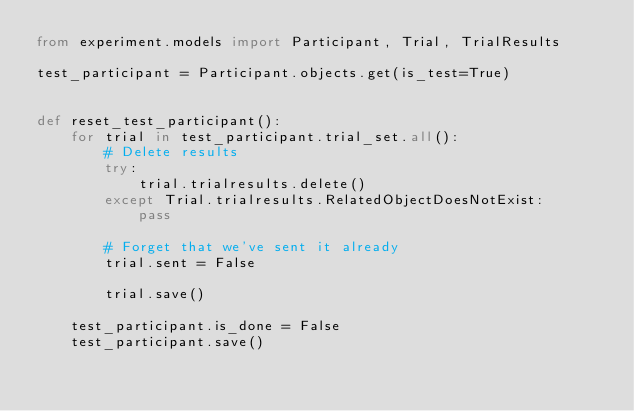Convert code to text. <code><loc_0><loc_0><loc_500><loc_500><_Python_>from experiment.models import Participant, Trial, TrialResults

test_participant = Participant.objects.get(is_test=True)


def reset_test_participant():
    for trial in test_participant.trial_set.all():
        # Delete results
        try:
            trial.trialresults.delete()
        except Trial.trialresults.RelatedObjectDoesNotExist:
            pass

        # Forget that we've sent it already
        trial.sent = False

        trial.save()

    test_participant.is_done = False
    test_participant.save()
</code> 